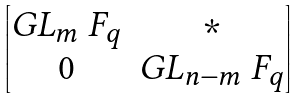<formula> <loc_0><loc_0><loc_500><loc_500>\begin{bmatrix} G L _ { m } \ F _ { q } & \ast \\ 0 & G L _ { n - m } \ F _ { q } \end{bmatrix}</formula> 